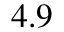<formula> <loc_0><loc_0><loc_500><loc_500>4 . 9</formula> 